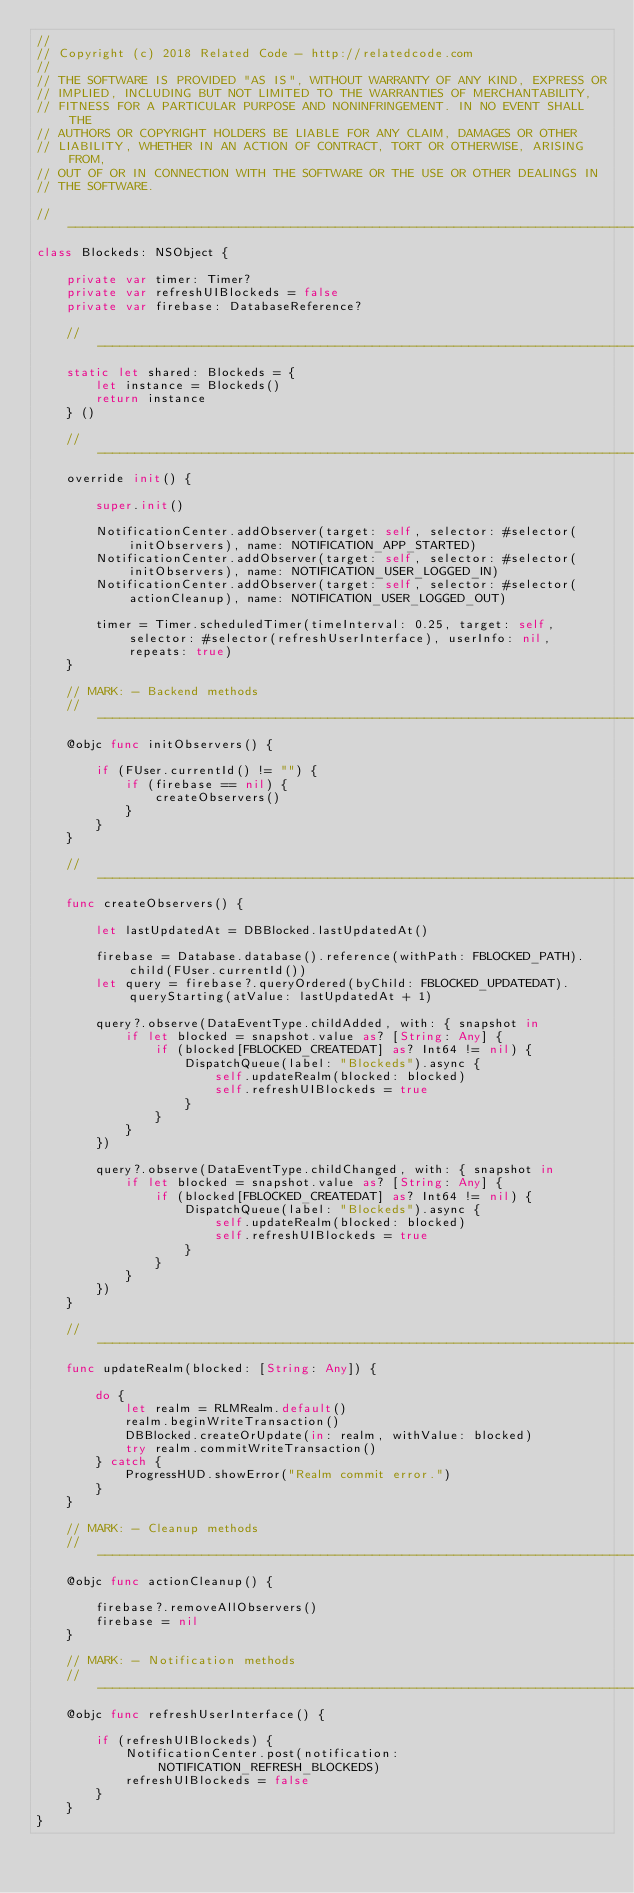Convert code to text. <code><loc_0><loc_0><loc_500><loc_500><_Swift_>//
// Copyright (c) 2018 Related Code - http://relatedcode.com
//
// THE SOFTWARE IS PROVIDED "AS IS", WITHOUT WARRANTY OF ANY KIND, EXPRESS OR
// IMPLIED, INCLUDING BUT NOT LIMITED TO THE WARRANTIES OF MERCHANTABILITY,
// FITNESS FOR A PARTICULAR PURPOSE AND NONINFRINGEMENT. IN NO EVENT SHALL THE
// AUTHORS OR COPYRIGHT HOLDERS BE LIABLE FOR ANY CLAIM, DAMAGES OR OTHER
// LIABILITY, WHETHER IN AN ACTION OF CONTRACT, TORT OR OTHERWISE, ARISING FROM,
// OUT OF OR IN CONNECTION WITH THE SOFTWARE OR THE USE OR OTHER DEALINGS IN
// THE SOFTWARE.

//-------------------------------------------------------------------------------------------------------------------------------------------------
class Blockeds: NSObject {

	private var timer: Timer?
	private var refreshUIBlockeds = false
	private var firebase: DatabaseReference?

	//---------------------------------------------------------------------------------------------------------------------------------------------
	static let shared: Blockeds = {
		let instance = Blockeds()
		return instance
	} ()

	//---------------------------------------------------------------------------------------------------------------------------------------------
	override init() {

		super.init()

		NotificationCenter.addObserver(target: self, selector: #selector(initObservers), name: NOTIFICATION_APP_STARTED)
		NotificationCenter.addObserver(target: self, selector: #selector(initObservers), name: NOTIFICATION_USER_LOGGED_IN)
		NotificationCenter.addObserver(target: self, selector: #selector(actionCleanup), name: NOTIFICATION_USER_LOGGED_OUT)

		timer = Timer.scheduledTimer(timeInterval: 0.25, target: self, selector: #selector(refreshUserInterface), userInfo: nil, repeats: true)
	}

	// MARK: - Backend methods
	//---------------------------------------------------------------------------------------------------------------------------------------------
	@objc func initObservers() {

		if (FUser.currentId() != "") {
			if (firebase == nil) {
				createObservers()
			}
		}
	}

	//---------------------------------------------------------------------------------------------------------------------------------------------
	func createObservers() {

		let lastUpdatedAt = DBBlocked.lastUpdatedAt()

		firebase = Database.database().reference(withPath: FBLOCKED_PATH).child(FUser.currentId())
		let query = firebase?.queryOrdered(byChild: FBLOCKED_UPDATEDAT).queryStarting(atValue: lastUpdatedAt + 1)

		query?.observe(DataEventType.childAdded, with: { snapshot in
			if let blocked = snapshot.value as? [String: Any] {
				if (blocked[FBLOCKED_CREATEDAT] as? Int64 != nil) {
					DispatchQueue(label: "Blockeds").async {
						self.updateRealm(blocked: blocked)
						self.refreshUIBlockeds = true
					}
				}
			}
		})

		query?.observe(DataEventType.childChanged, with: { snapshot in
			if let blocked = snapshot.value as? [String: Any] {
				if (blocked[FBLOCKED_CREATEDAT] as? Int64 != nil) {
					DispatchQueue(label: "Blockeds").async {
						self.updateRealm(blocked: blocked)
						self.refreshUIBlockeds = true
					}
				}
			}
		})
	}

	//---------------------------------------------------------------------------------------------------------------------------------------------
	func updateRealm(blocked: [String: Any]) {

		do {
			let realm = RLMRealm.default()
			realm.beginWriteTransaction()
			DBBlocked.createOrUpdate(in: realm, withValue: blocked)
			try realm.commitWriteTransaction()
		} catch {
			ProgressHUD.showError("Realm commit error.")
		}
	}

	// MARK: - Cleanup methods
	//---------------------------------------------------------------------------------------------------------------------------------------------
	@objc func actionCleanup() {

		firebase?.removeAllObservers()
		firebase = nil
	}

	// MARK: - Notification methods
	//---------------------------------------------------------------------------------------------------------------------------------------------
	@objc func refreshUserInterface() {

		if (refreshUIBlockeds) {
			NotificationCenter.post(notification: NOTIFICATION_REFRESH_BLOCKEDS)
			refreshUIBlockeds = false
		}
	}
}
</code> 